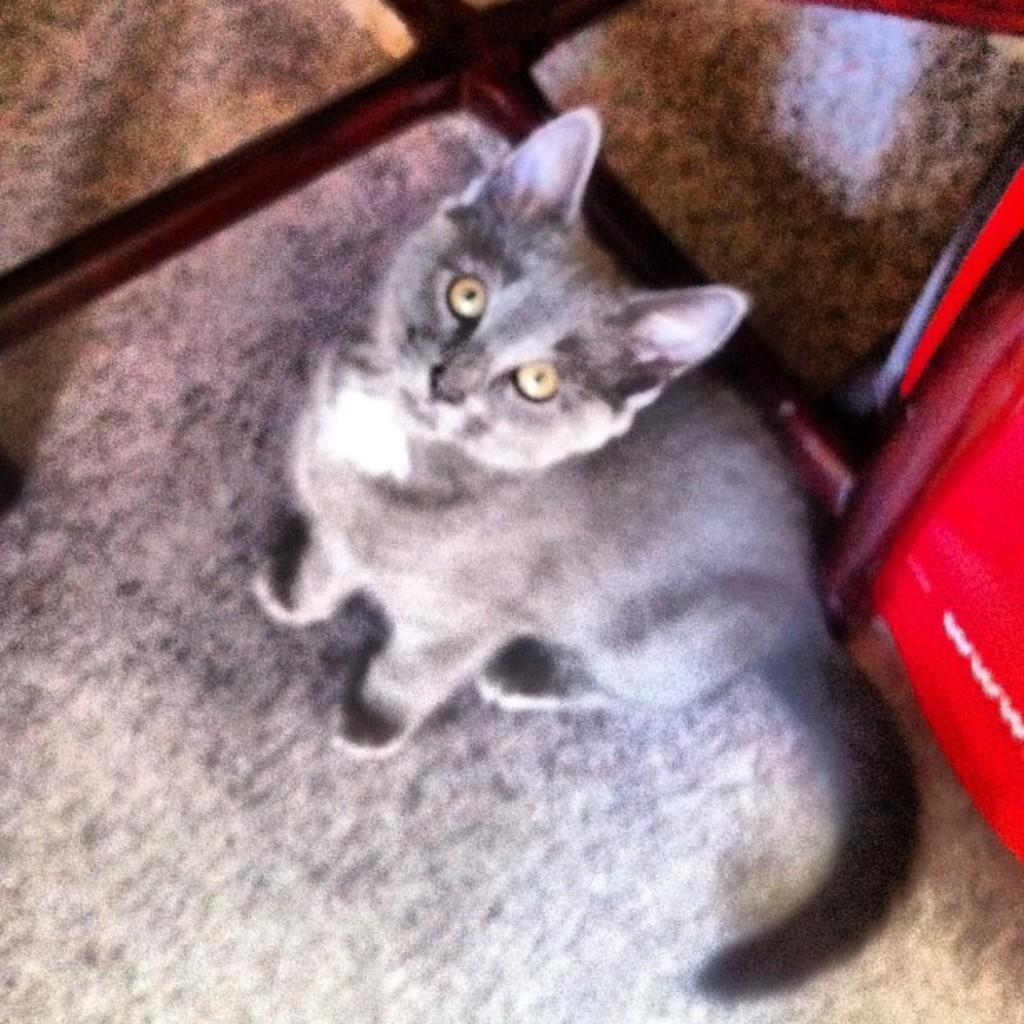What animal is present in the picture? There is a cat in the picture. Where is the cat located in the picture? The cat is sitting on the floor. What color is the cat? The cat is grey in color. What can be observed about the cat's eyes? The cat has yellow eyes. Is the cat holding an umbrella in the picture? No, the cat is not holding an umbrella in the picture. Is there a carpenter working on a project in the picture? No, there is no carpenter or any indication of a project in the picture. 